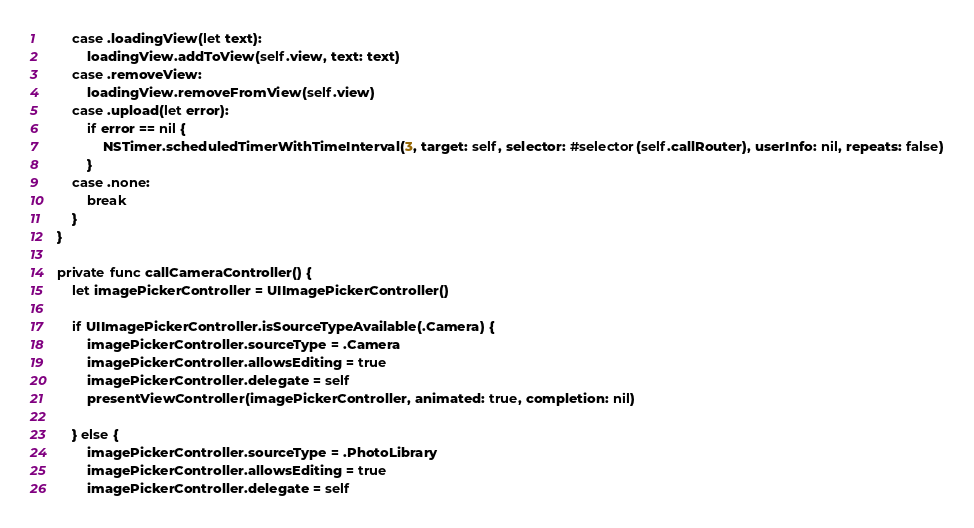<code> <loc_0><loc_0><loc_500><loc_500><_Swift_>        case .loadingView(let text):
            loadingView.addToView(self.view, text: text)
        case .removeView:
            loadingView.removeFromView(self.view)
        case .upload(let error):
            if error == nil {
                NSTimer.scheduledTimerWithTimeInterval(3, target: self, selector: #selector(self.callRouter), userInfo: nil, repeats: false)
            }
        case .none:
            break
        }
    }
    
    private func callCameraController() {
        let imagePickerController = UIImagePickerController()
        
        if UIImagePickerController.isSourceTypeAvailable(.Camera) {
            imagePickerController.sourceType = .Camera
            imagePickerController.allowsEditing = true
            imagePickerController.delegate = self
            presentViewController(imagePickerController, animated: true, completion: nil)
            
        } else {
            imagePickerController.sourceType = .PhotoLibrary
            imagePickerController.allowsEditing = true
            imagePickerController.delegate = self</code> 